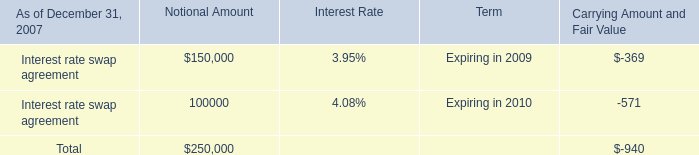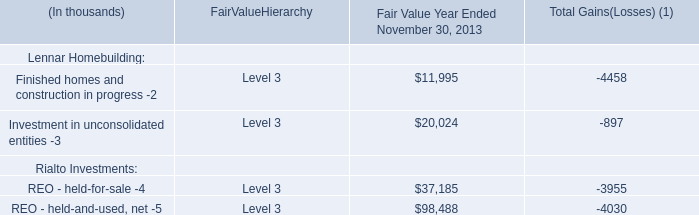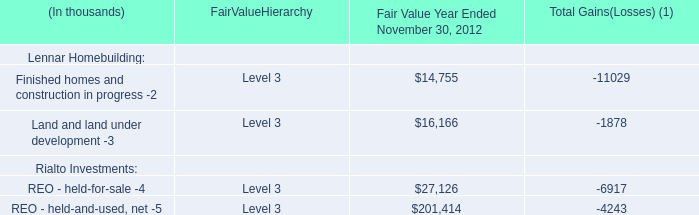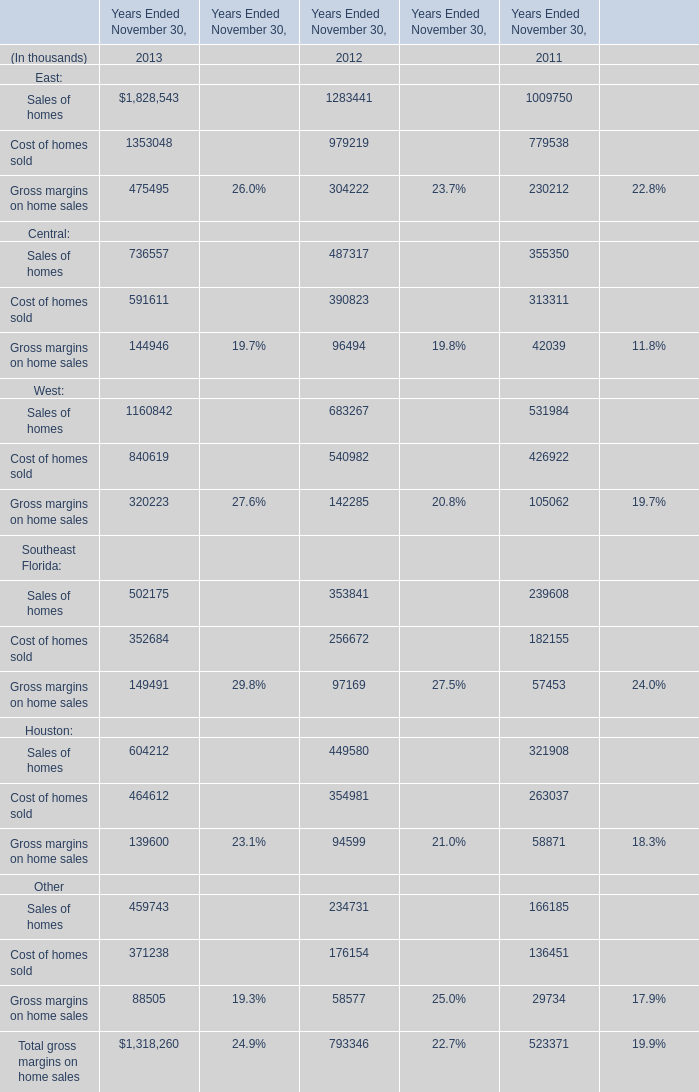What is the growth rate of Total gross margins on home sales between 2011 and 2012 in terms of Years Ended November 30? 
Computations: ((793346 - 523371) / 523371)
Answer: 0.51584. 